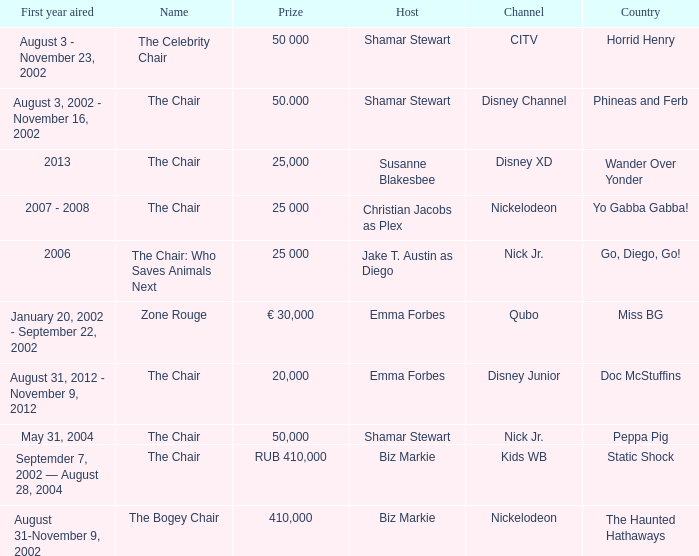What was the first year that had a prize of 50,000? May 31, 2004. 